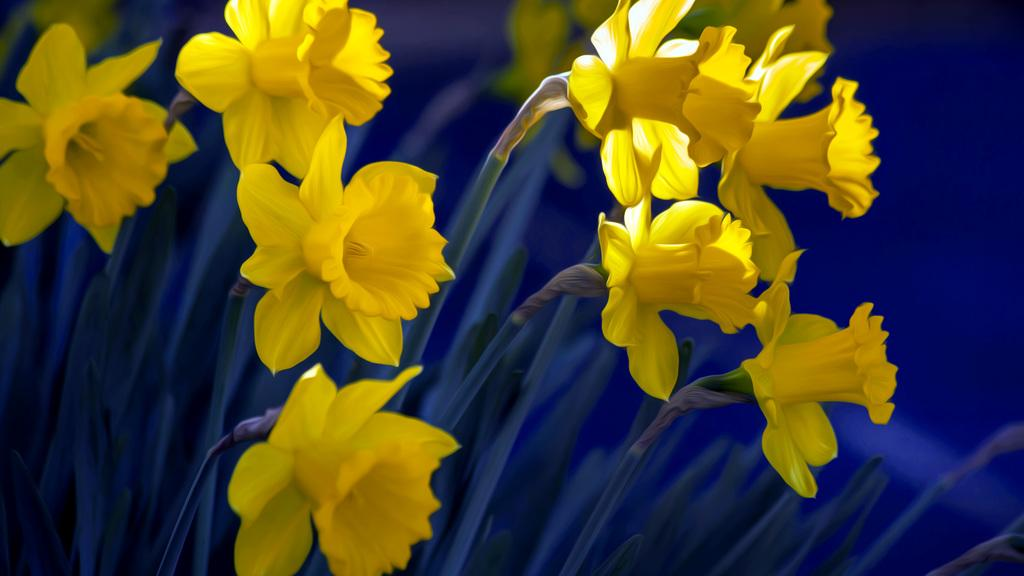What color are the flowers on the plants in the image? The flowers on the plants in the image are yellow. What can be seen on the right side of the image? There is a road on the right side of the image. Where is the toothbrush located in the image? There is no toothbrush present in the image. What type of ornament can be seen hanging from the flowers in the image? There are no ornaments present in the image; it only features yellow flowers on plants. 